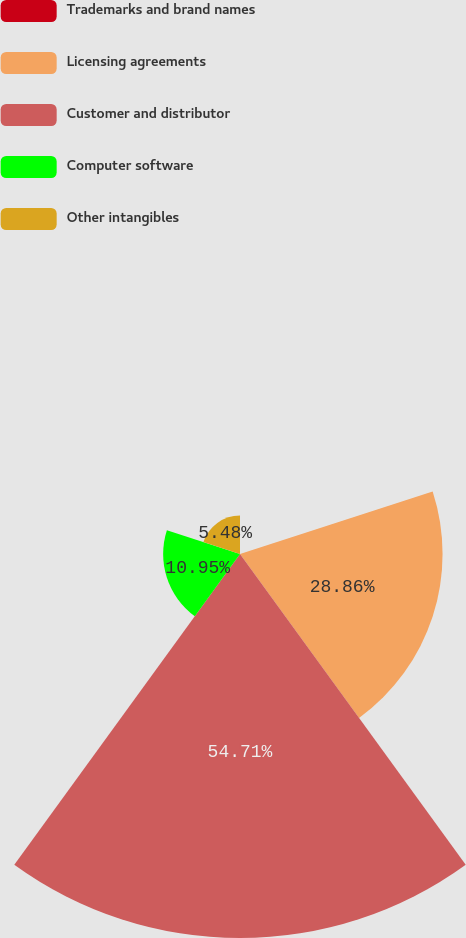Convert chart to OTSL. <chart><loc_0><loc_0><loc_500><loc_500><pie_chart><fcel>Trademarks and brand names<fcel>Licensing agreements<fcel>Customer and distributor<fcel>Computer software<fcel>Other intangibles<nl><fcel>0.0%<fcel>28.86%<fcel>54.71%<fcel>10.95%<fcel>5.48%<nl></chart> 